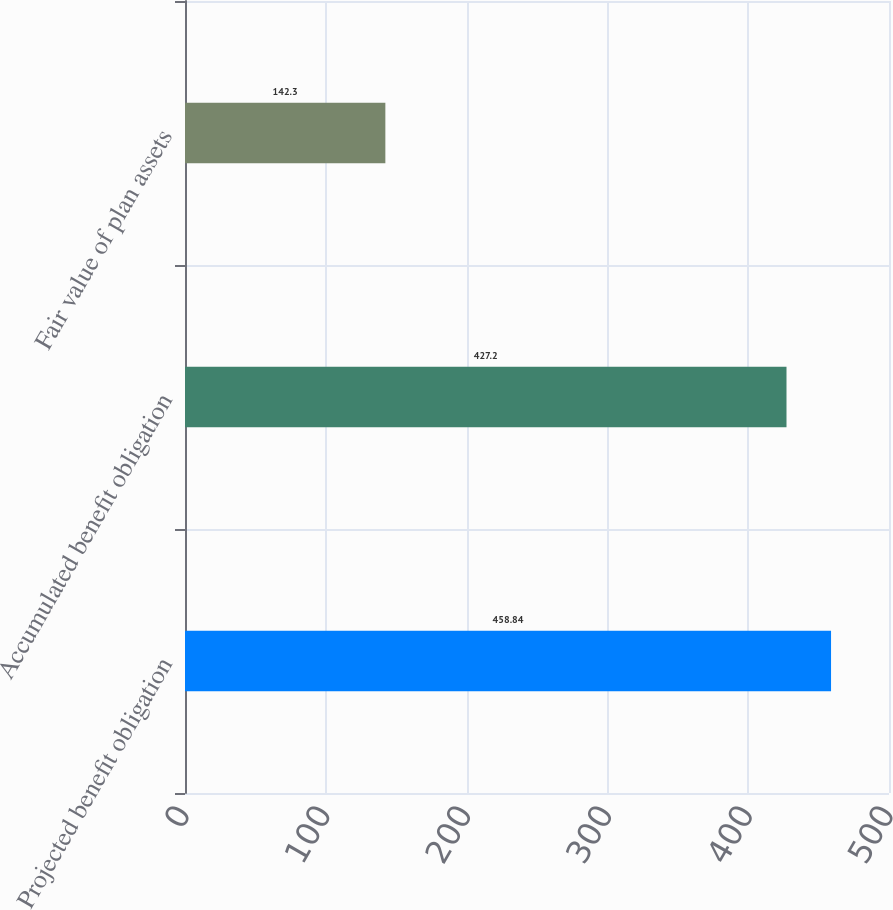<chart> <loc_0><loc_0><loc_500><loc_500><bar_chart><fcel>Projected benefit obligation<fcel>Accumulated benefit obligation<fcel>Fair value of plan assets<nl><fcel>458.84<fcel>427.2<fcel>142.3<nl></chart> 